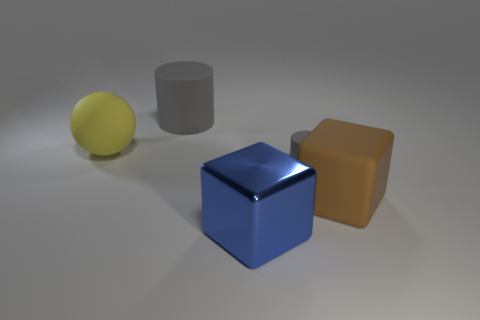Subtract all blue blocks. How many blocks are left? 1 Subtract 2 cylinders. How many cylinders are left? 0 Subtract all blocks. How many objects are left? 3 Subtract all gray cylinders. How many purple spheres are left? 0 Subtract all red rubber things. Subtract all metal blocks. How many objects are left? 4 Add 2 rubber blocks. How many rubber blocks are left? 3 Add 4 yellow objects. How many yellow objects exist? 5 Add 5 brown objects. How many objects exist? 10 Subtract 0 green balls. How many objects are left? 5 Subtract all brown balls. Subtract all cyan blocks. How many balls are left? 1 